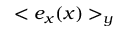Convert formula to latex. <formula><loc_0><loc_0><loc_500><loc_500>< e _ { x } ( x ) > _ { y }</formula> 